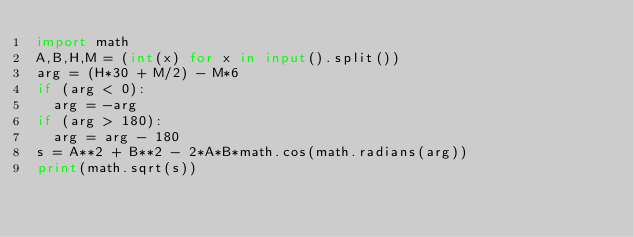Convert code to text. <code><loc_0><loc_0><loc_500><loc_500><_Python_>import math
A,B,H,M = (int(x) for x in input().split())
arg = (H*30 + M/2) - M*6
if (arg < 0):
  arg = -arg
if (arg > 180):
  arg = arg - 180
s = A**2 + B**2 - 2*A*B*math.cos(math.radians(arg))
print(math.sqrt(s))</code> 